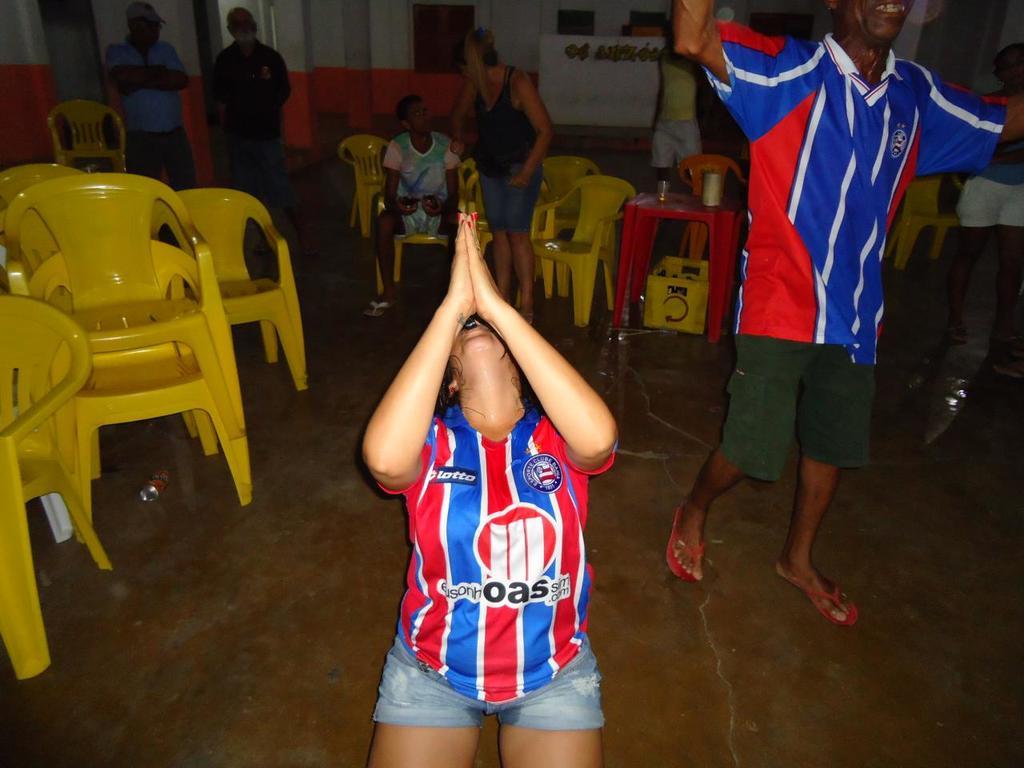What is the teams sponsor?
Give a very brief answer. Oas. 